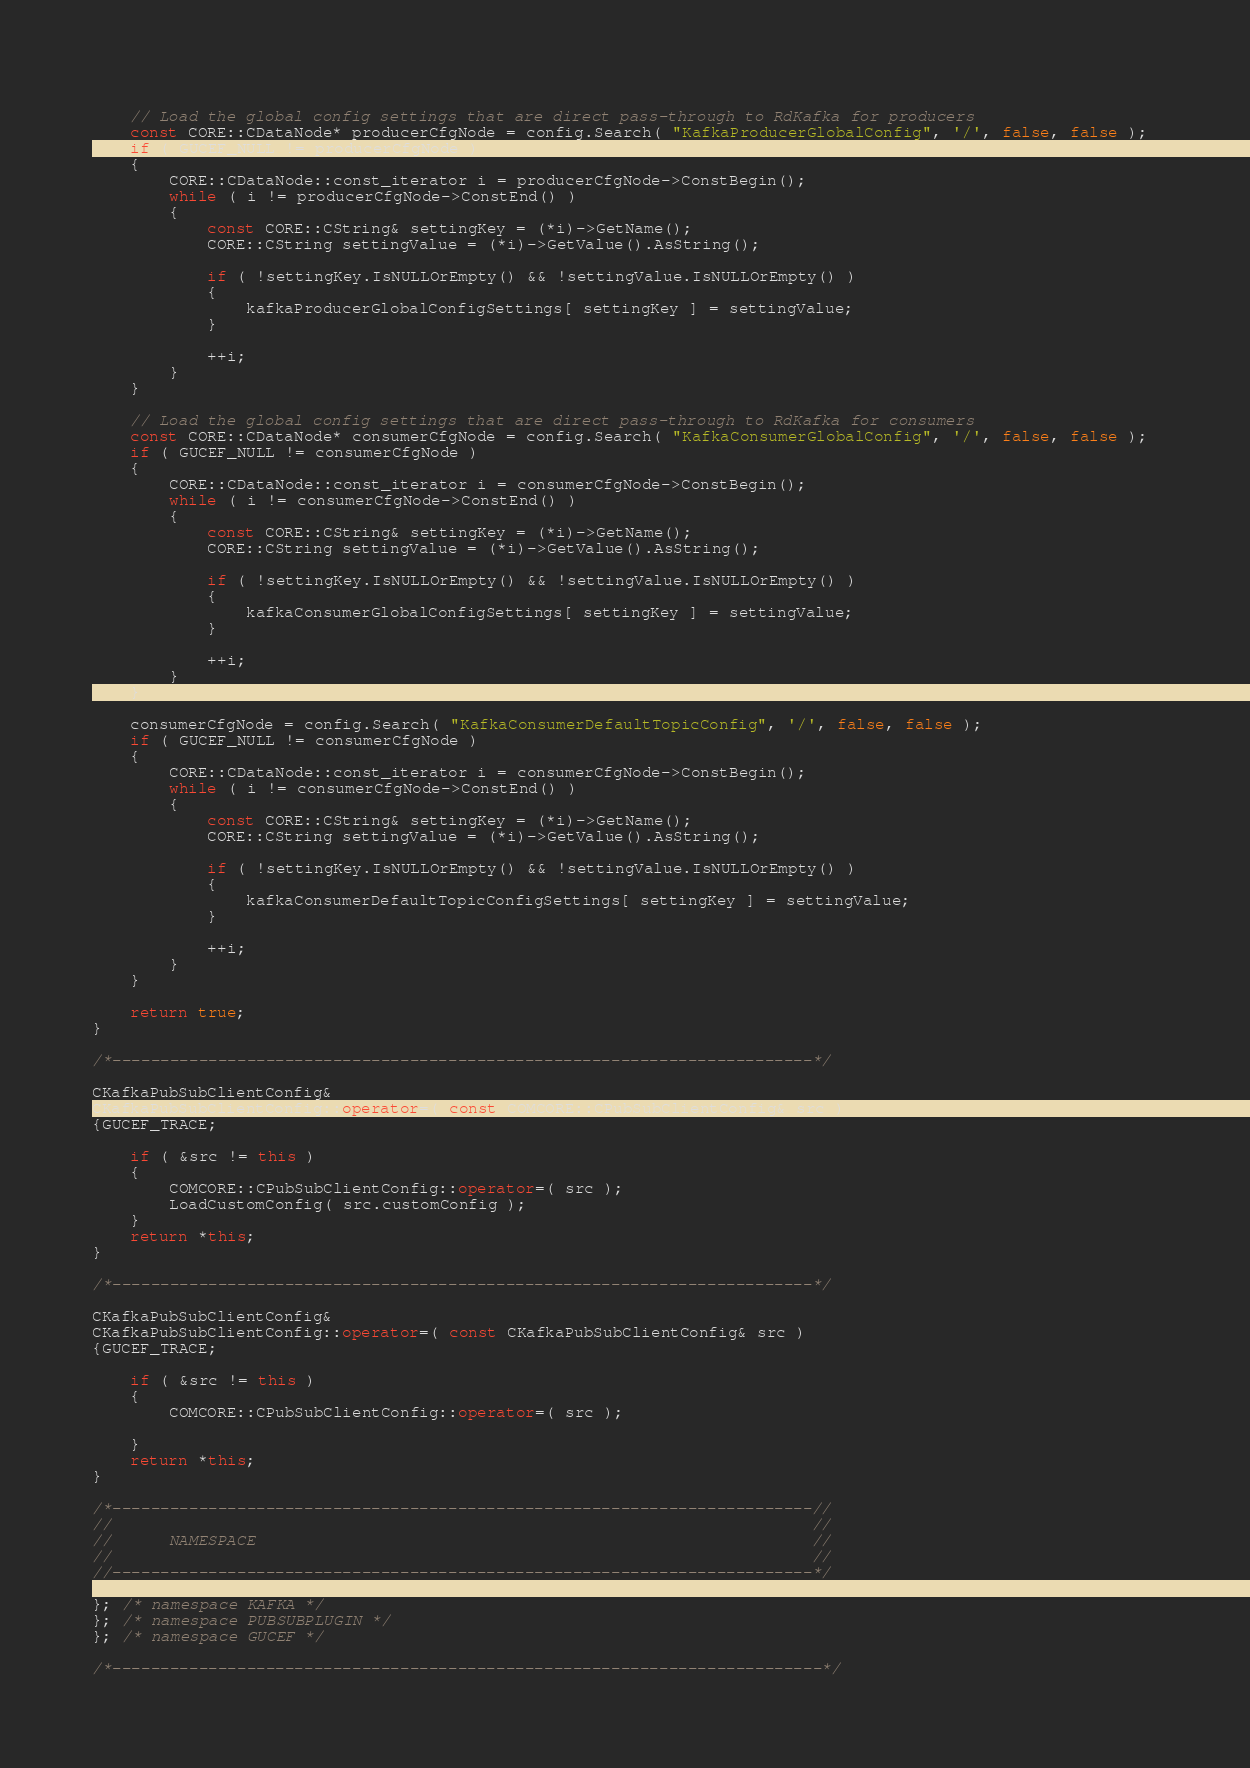Convert code to text. <code><loc_0><loc_0><loc_500><loc_500><_C++_>    
    // Load the global config settings that are direct pass-through to RdKafka for producers
    const CORE::CDataNode* producerCfgNode = config.Search( "KafkaProducerGlobalConfig", '/', false, false ); 
    if ( GUCEF_NULL != producerCfgNode )
    {
        CORE::CDataNode::const_iterator i = producerCfgNode->ConstBegin();
        while ( i != producerCfgNode->ConstEnd() )
        {
            const CORE::CString& settingKey = (*i)->GetName();
            CORE::CString settingValue = (*i)->GetValue().AsString();

            if ( !settingKey.IsNULLOrEmpty() && !settingValue.IsNULLOrEmpty() )
            {
                kafkaProducerGlobalConfigSettings[ settingKey ] = settingValue; 
            }
            
            ++i;
        }
    }

    // Load the global config settings that are direct pass-through to RdKafka for consumers
    const CORE::CDataNode* consumerCfgNode = config.Search( "KafkaConsumerGlobalConfig", '/', false, false ); 
    if ( GUCEF_NULL != consumerCfgNode )
    {
        CORE::CDataNode::const_iterator i = consumerCfgNode->ConstBegin();
        while ( i != consumerCfgNode->ConstEnd() )
        {
            const CORE::CString& settingKey = (*i)->GetName();
            CORE::CString settingValue = (*i)->GetValue().AsString();

            if ( !settingKey.IsNULLOrEmpty() && !settingValue.IsNULLOrEmpty() )
            {
                kafkaConsumerGlobalConfigSettings[ settingKey ] = settingValue; 
            }
            
            ++i;
        }
    }

    consumerCfgNode = config.Search( "KafkaConsumerDefaultTopicConfig", '/', false, false ); 
    if ( GUCEF_NULL != consumerCfgNode )
    {
        CORE::CDataNode::const_iterator i = consumerCfgNode->ConstBegin();
        while ( i != consumerCfgNode->ConstEnd() )
        {
            const CORE::CString& settingKey = (*i)->GetName();
            CORE::CString settingValue = (*i)->GetValue().AsString();

            if ( !settingKey.IsNULLOrEmpty() && !settingValue.IsNULLOrEmpty() )
            {
                kafkaConsumerDefaultTopicConfigSettings[ settingKey ] = settingValue; 
            }
            
            ++i;
        }
    }

    return true;
}

/*-------------------------------------------------------------------------*/

CKafkaPubSubClientConfig& 
CKafkaPubSubClientConfig::operator=( const COMCORE::CPubSubClientConfig& src )
{GUCEF_TRACE;

    if ( &src != this )
    {
        COMCORE::CPubSubClientConfig::operator=( src );
        LoadCustomConfig( src.customConfig );    
    }
    return *this;
}

/*-------------------------------------------------------------------------*/

CKafkaPubSubClientConfig& 
CKafkaPubSubClientConfig::operator=( const CKafkaPubSubClientConfig& src )
{GUCEF_TRACE;

    if ( &src != this )
    {
        COMCORE::CPubSubClientConfig::operator=( src );

    }
    return *this;
}

/*-------------------------------------------------------------------------//
//                                                                         //
//      NAMESPACE                                                          //
//                                                                         //
//-------------------------------------------------------------------------*/

}; /* namespace KAFKA */
}; /* namespace PUBSUBPLUGIN */
}; /* namespace GUCEF */

/*--------------------------------------------------------------------------*/
</code> 